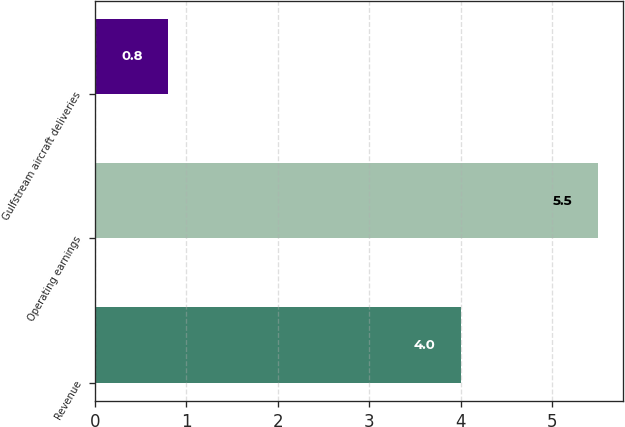<chart> <loc_0><loc_0><loc_500><loc_500><bar_chart><fcel>Revenue<fcel>Operating earnings<fcel>Gulfstream aircraft deliveries<nl><fcel>4<fcel>5.5<fcel>0.8<nl></chart> 